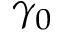Convert formula to latex. <formula><loc_0><loc_0><loc_500><loc_500>\gamma _ { 0 }</formula> 